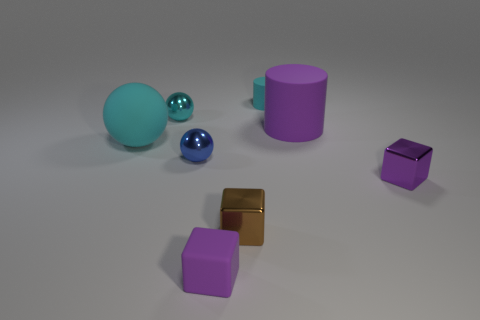Subtract all spheres. How many objects are left? 5 Add 1 big purple matte cylinders. How many objects exist? 9 Subtract 1 brown cubes. How many objects are left? 7 Subtract all tiny purple matte blocks. Subtract all tiny brown cubes. How many objects are left? 6 Add 5 tiny spheres. How many tiny spheres are left? 7 Add 6 yellow rubber things. How many yellow rubber things exist? 6 